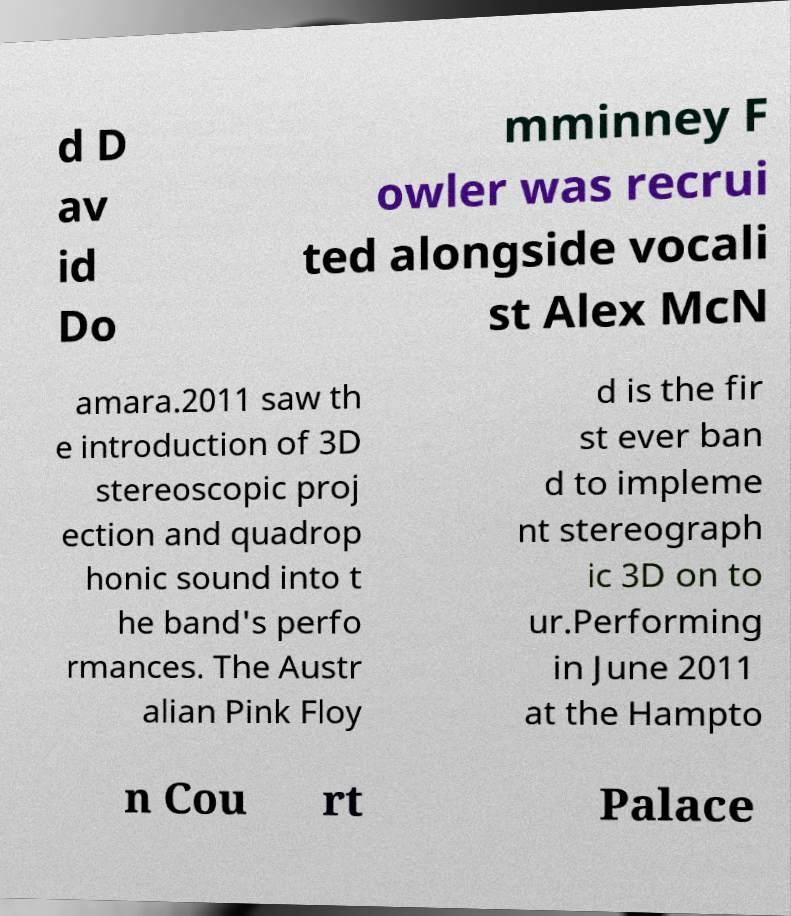What messages or text are displayed in this image? I need them in a readable, typed format. d D av id Do mminney F owler was recrui ted alongside vocali st Alex McN amara.2011 saw th e introduction of 3D stereoscopic proj ection and quadrop honic sound into t he band's perfo rmances. The Austr alian Pink Floy d is the fir st ever ban d to impleme nt stereograph ic 3D on to ur.Performing in June 2011 at the Hampto n Cou rt Palace 